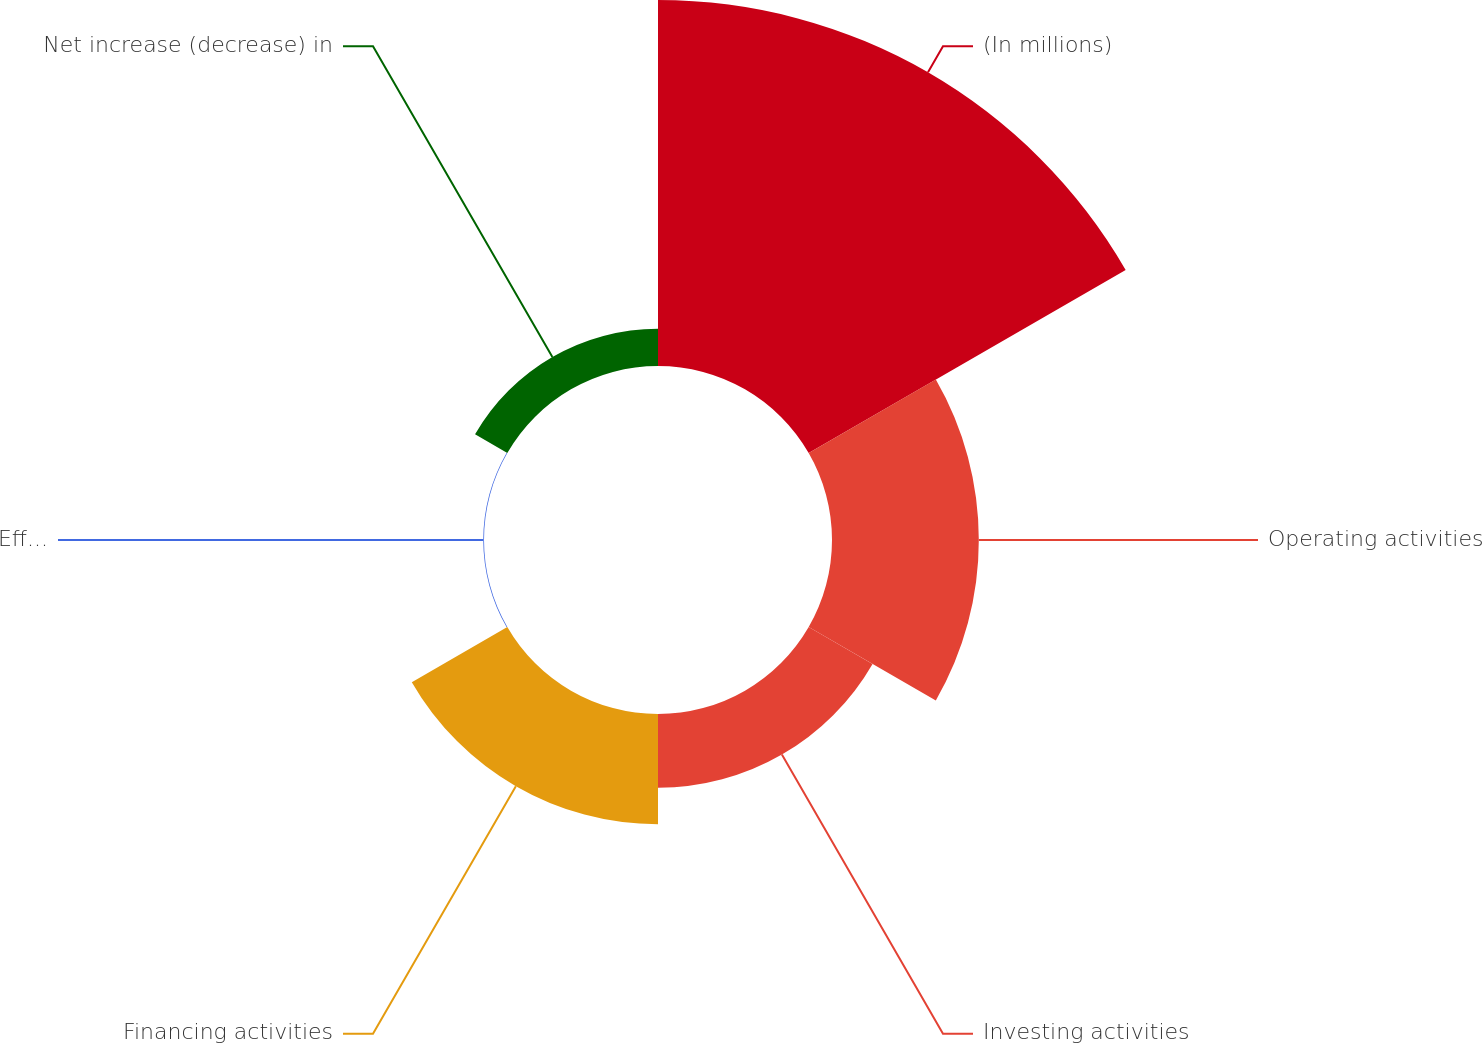<chart> <loc_0><loc_0><loc_500><loc_500><pie_chart><fcel>(In millions)<fcel>Operating activities<fcel>Investing activities<fcel>Financing activities<fcel>Effects of exchange rate<fcel>Net increase (decrease) in<nl><fcel>49.81%<fcel>19.98%<fcel>10.04%<fcel>15.01%<fcel>0.1%<fcel>5.07%<nl></chart> 